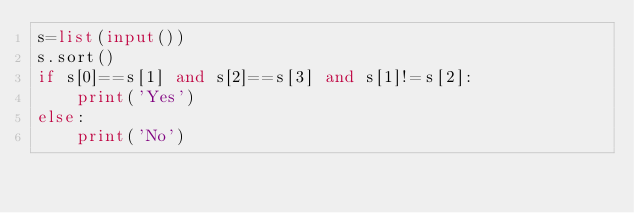Convert code to text. <code><loc_0><loc_0><loc_500><loc_500><_Python_>s=list(input())
s.sort()
if s[0]==s[1] and s[2]==s[3] and s[1]!=s[2]:
    print('Yes')
else:
    print('No')</code> 